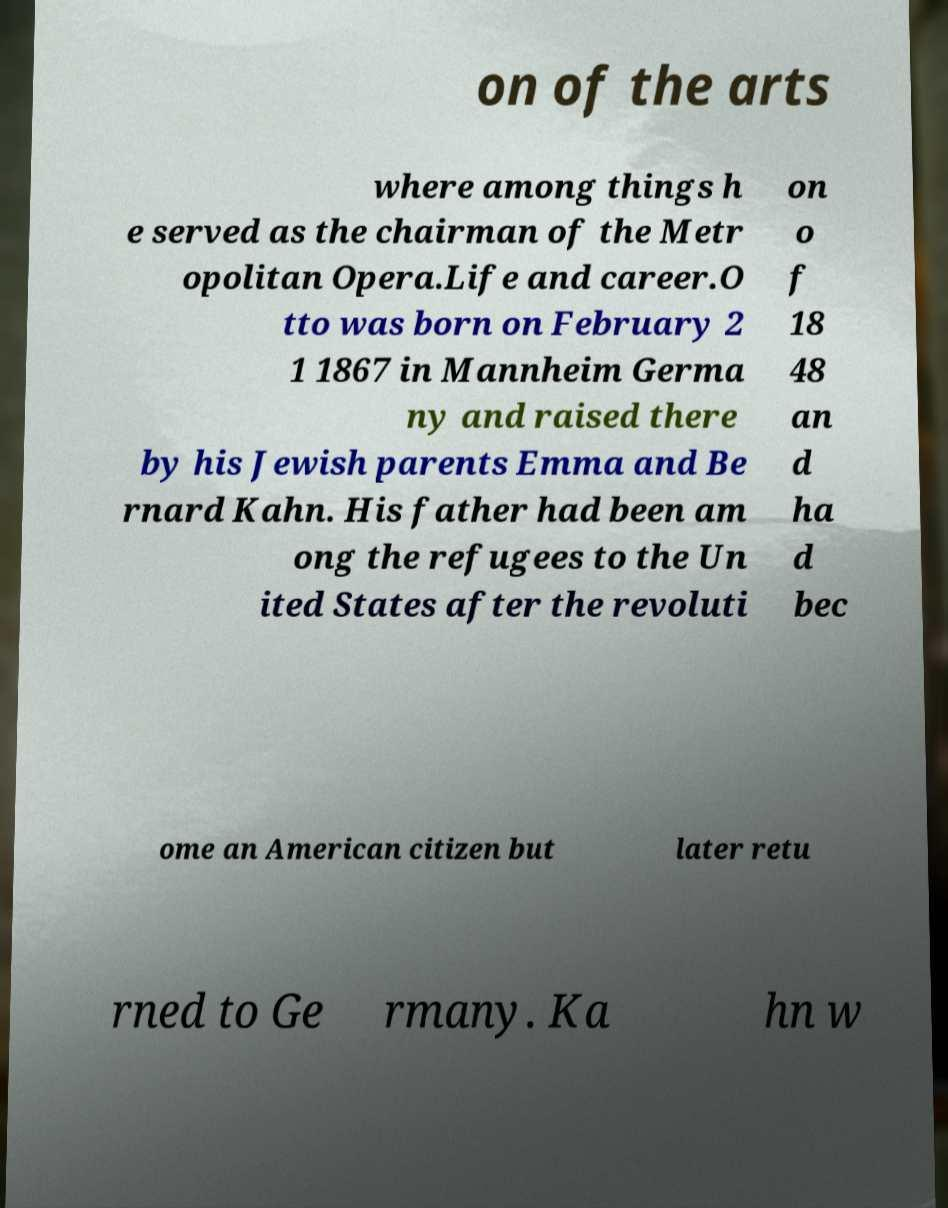Could you extract and type out the text from this image? on of the arts where among things h e served as the chairman of the Metr opolitan Opera.Life and career.O tto was born on February 2 1 1867 in Mannheim Germa ny and raised there by his Jewish parents Emma and Be rnard Kahn. His father had been am ong the refugees to the Un ited States after the revoluti on o f 18 48 an d ha d bec ome an American citizen but later retu rned to Ge rmany. Ka hn w 